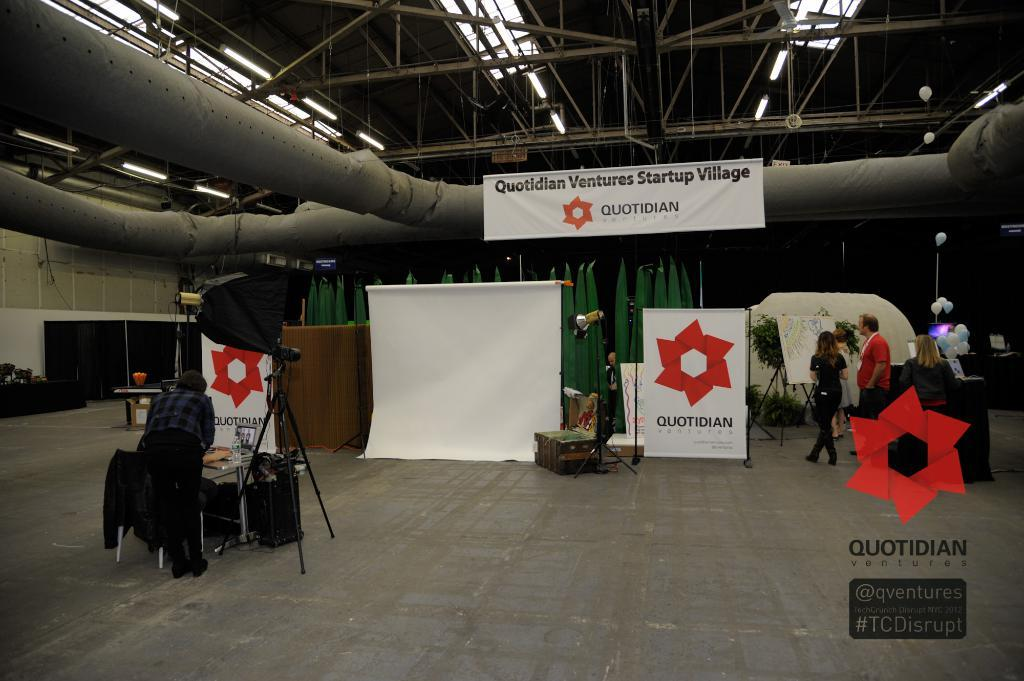<image>
Render a clear and concise summary of the photo. A white banner bearing the name Quotidian is hung on a pipe. 